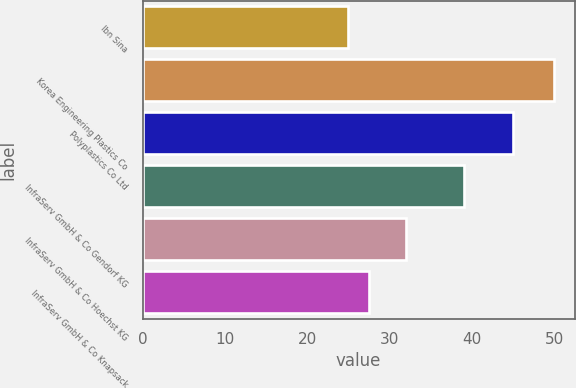<chart> <loc_0><loc_0><loc_500><loc_500><bar_chart><fcel>Ibn Sina<fcel>Korea Engineering Plastics Co<fcel>Polyplastics Co Ltd<fcel>InfraServ GmbH & Co Gendorf KG<fcel>InfraServ GmbH & Co Hoechst KG<fcel>InfraServ GmbH & Co Knapsack<nl><fcel>25<fcel>50<fcel>45<fcel>39<fcel>32<fcel>27.5<nl></chart> 